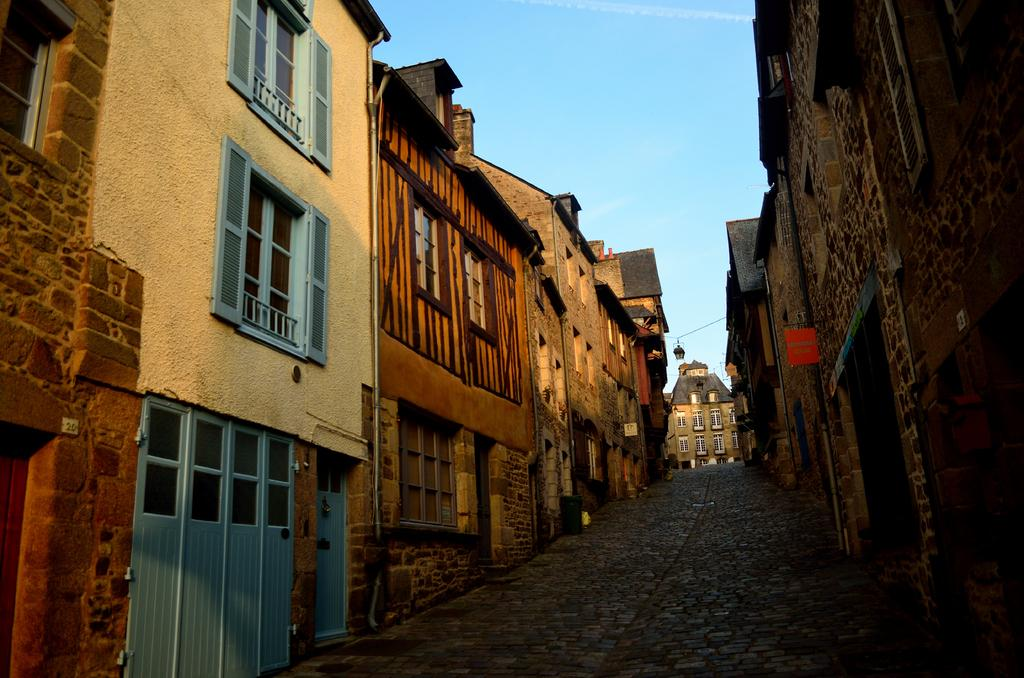What type of structures can be seen in the image? There are buildings in the image. What architectural features are visible on the buildings? There are windows and doors visible on the buildings. What part of the natural environment is visible in the image? The sky is visible in the image. How many clocks can be seen hanging on the walls of the buildings in the image? There is no information about clocks in the image, so we cannot determine how many there are. 